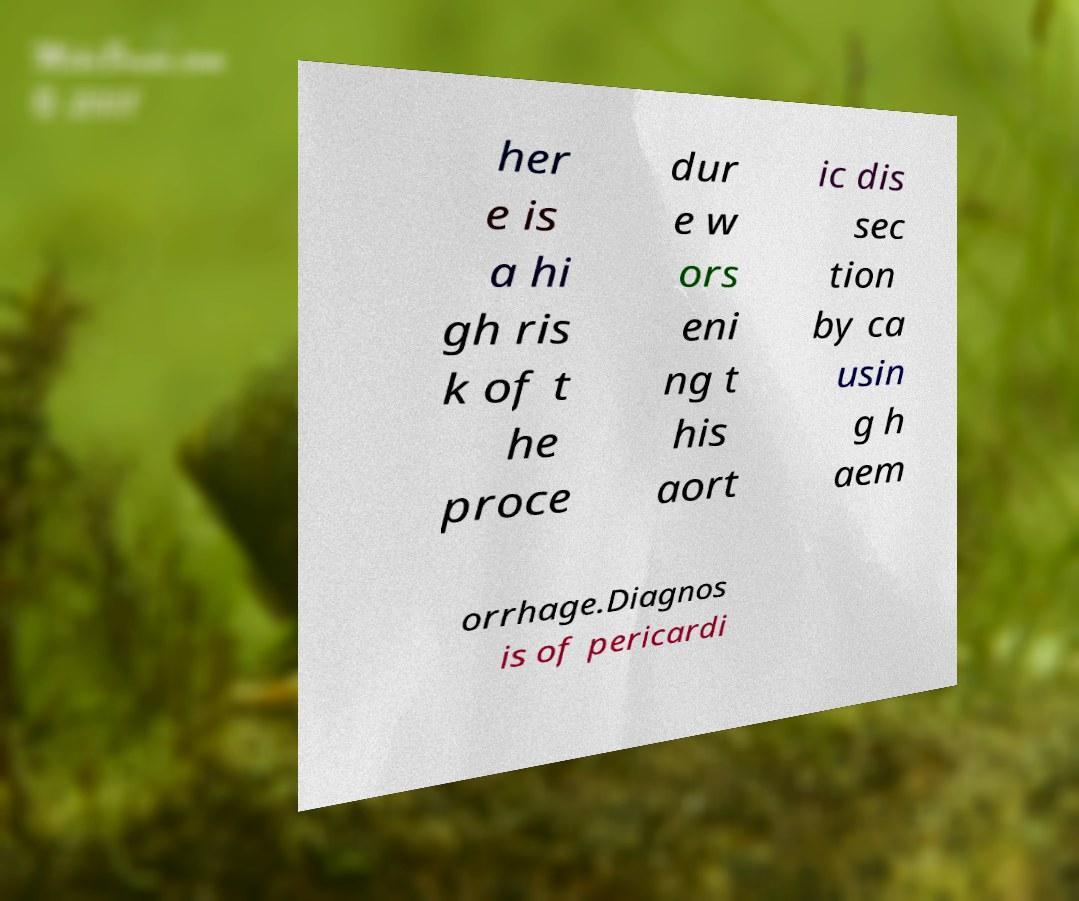What messages or text are displayed in this image? I need them in a readable, typed format. her e is a hi gh ris k of t he proce dur e w ors eni ng t his aort ic dis sec tion by ca usin g h aem orrhage.Diagnos is of pericardi 